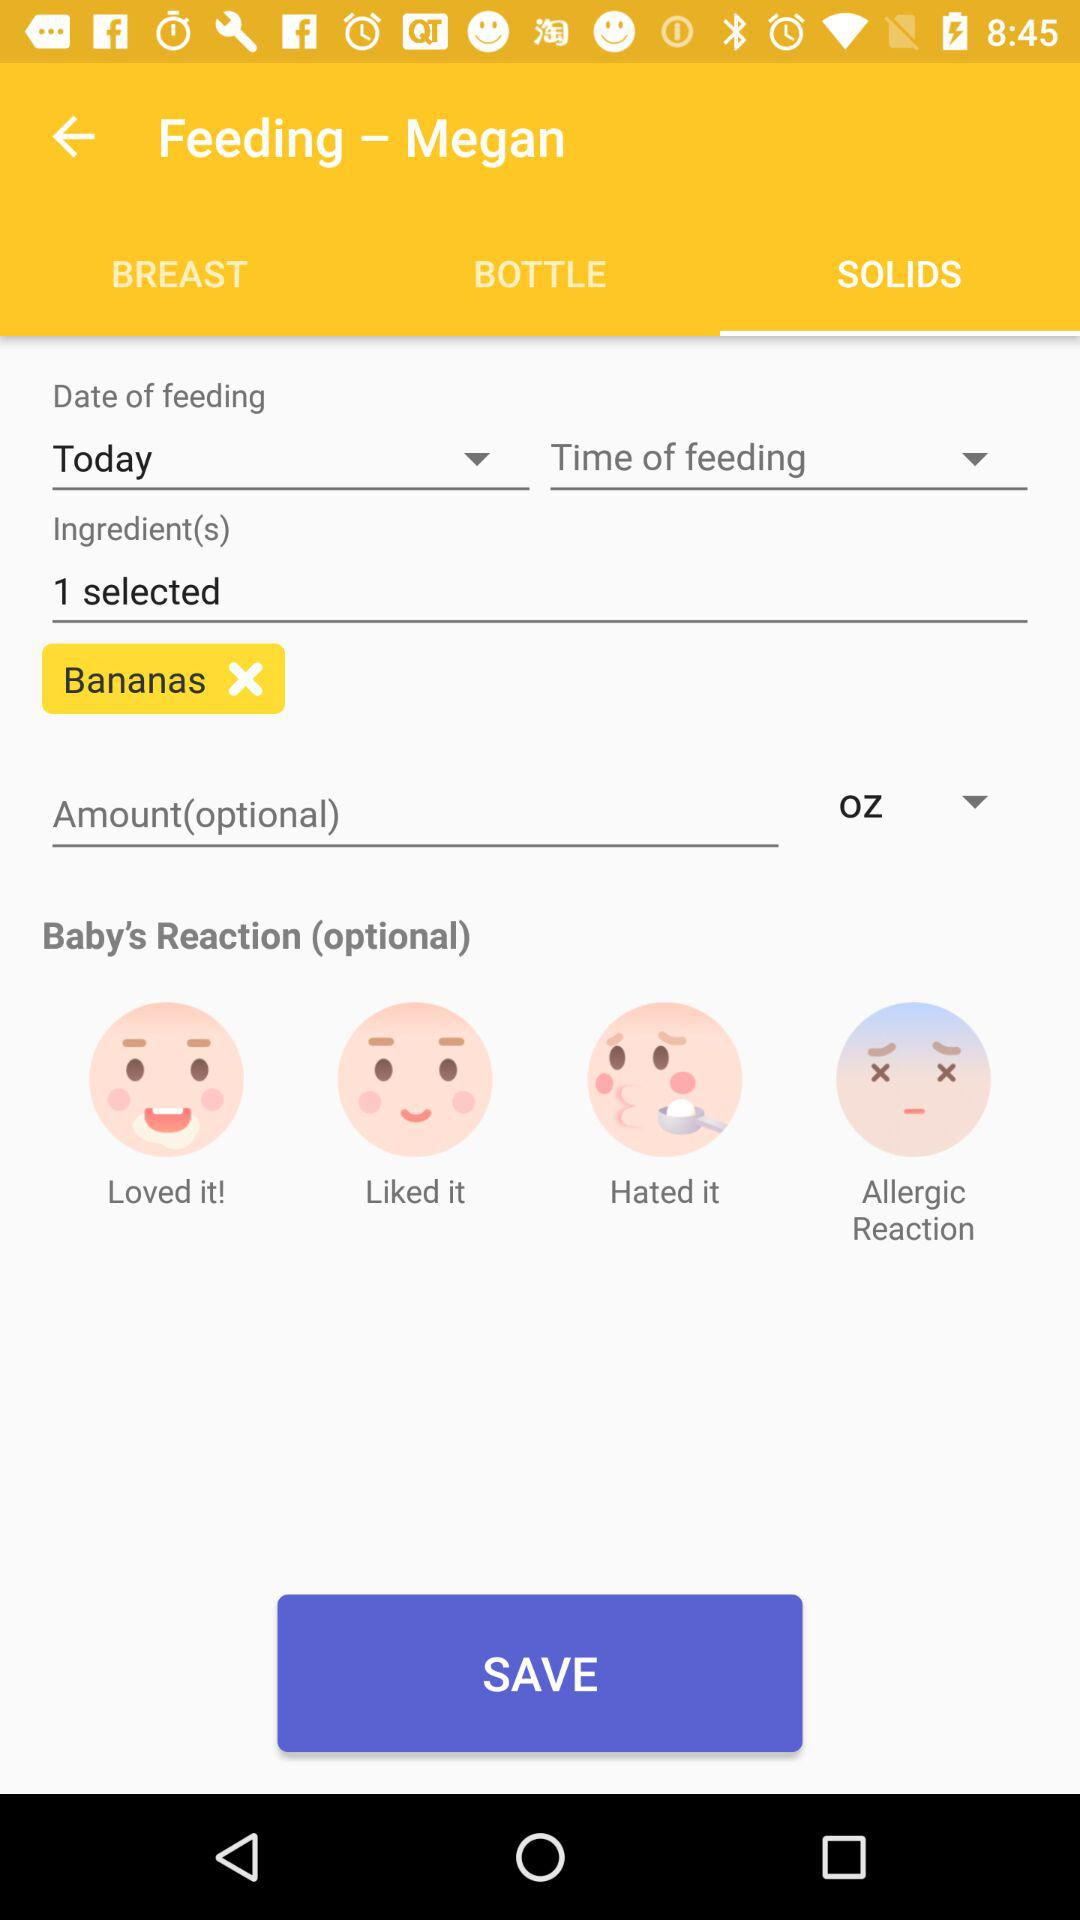How many ingredients are selected? There is 1 ingredient selected. 